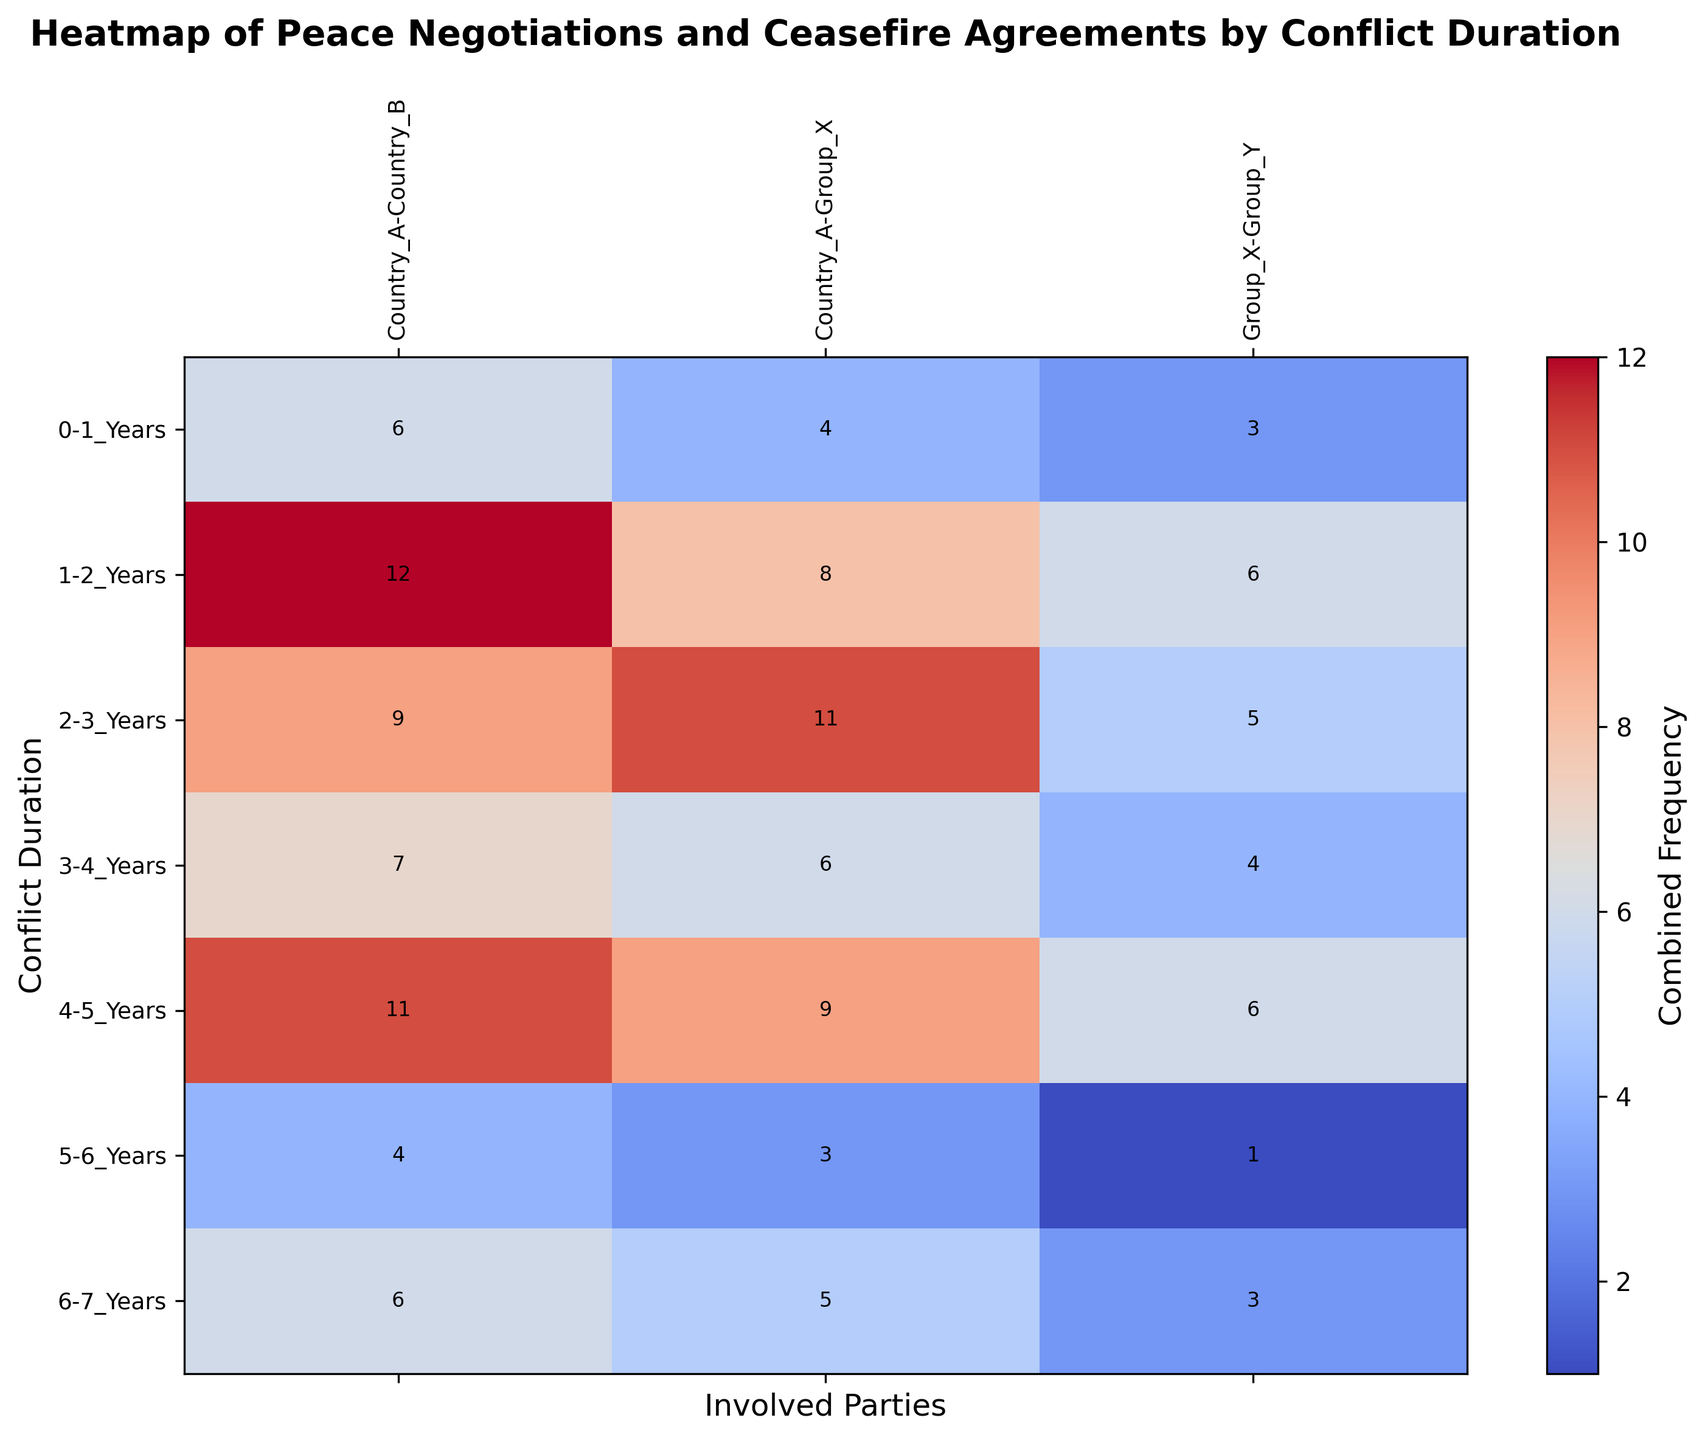Which combination of involved parties and conflict duration has the highest combined frequency of peace negotiations and ceasefire agreements? Look for the cell in the heatmap with the highest color intensity (brightness/darkness), and read off the corresponding row (conflict duration) and column (involved parties).
Answer: Country A - Country B, 1-2 Years Which conflict duration shows the lowest combined frequency of peace negotiations and ceasefire agreements involving Group X and Group Y? Identify the cells under the "Group X - Group Y" column, and find the one with the least color intensity.
Answer: 5-6 Years How does the combined frequency of peace negotiations and ceasefire agreements for Country A and Group X during 2-3 years compare with that during 3-4 years? Compare the color intensities of the cells under the "Country A - Group X" column for the rows "2-3 Years" and "3-4 Years." The one with the darker color has a higher frequency.
Answer: Higher in 2-3 Years What is the average combined frequency of peace negotiations and ceasefire agreements for conflicts lasting 4-5 years across all involved parties? Identify all cells in the row for "4-5 Years," sum their values, and divide by the number of involved parties. (7 + 6 + 4) / 3
Answer: 5.67 Is there any conflict duration where Country A and Country B have an equal combined frequency of peace negotiations and ceasefire agreements to that of Group X and Group Y? Compare the combined frequency values of "Country A - Country B" with those of "Group X - Group Y" for each conflict duration. Check if any of them are exactly equal.
Answer: No By how much does the combined frequency of peace negotiations and ceasefire agreements between Country A and Group X change from 1-2 years to 2-3 years? Subtract the value in the "2-3 Years" cell under "Country A - Group X" column from the value in the "1-2 Years" cell under the same column. 7 - 5
Answer: +2 What is the combined frequency value for conflicts lasting 6-7 years between Country A and Country B? Identify the cell at the intersection of "6-7 Years" and "Country A - Country B," and read off the value overlayed on the heatmap.
Answer: 6 Which conflict duration shows the highest combined frequency of peace negotiations and ceasefire agreements for Group X and Group Y? Look for the row under "Group X - Group Y" column with the highest color intensity (brightness/darkness).
Answer: 1-2 Years 